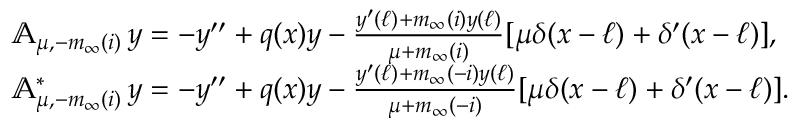Convert formula to latex. <formula><loc_0><loc_0><loc_500><loc_500>\begin{array} { r l } & { { \mathbb { A } } _ { \mu , - m _ { \infty } ( i ) } \, y = - y ^ { \prime \prime } + q ( x ) y - \frac { y ^ { \prime } ( \ell ) + m _ { \infty } ( i ) y ( \ell ) } { \mu + m _ { \infty } ( i ) } [ \mu \delta ( x - \ell ) + \delta ^ { \prime } ( x - \ell ) ] , } \\ & { { \mathbb { A } } _ { \mu , - m _ { \infty } ( i ) } ^ { * } \, y = - y ^ { \prime \prime } + q ( x ) y - \frac { y ^ { \prime } ( \ell ) + m _ { \infty } ( - i ) y ( \ell ) } { \mu + m _ { \infty } ( - i ) } [ \mu \delta ( x - \ell ) + \delta ^ { \prime } ( x - \ell ) ] . } \end{array}</formula> 